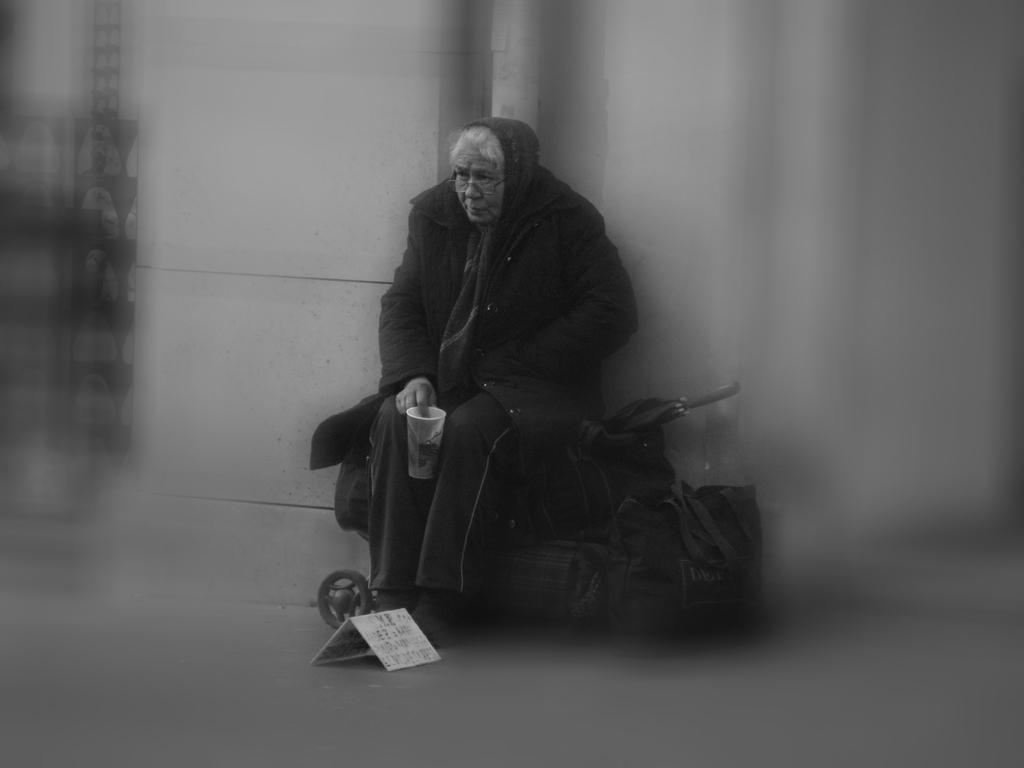What is the woman doing in the image? The woman is sitting on luggage bags in the image. What can be seen on the platform in the image? There is a card on the platform in the image. What object is behind the woman in the image? There is an umbrella behind the woman in the image. How would you describe the edges of the image? The sides of the image are blurred. What is the writer doing in the image? There is no writer present in the image. What type of development can be seen in the image? There is no development visible in the image; it features a woman sitting on luggage bags, a card on the platform, and an umbrella behind her. 